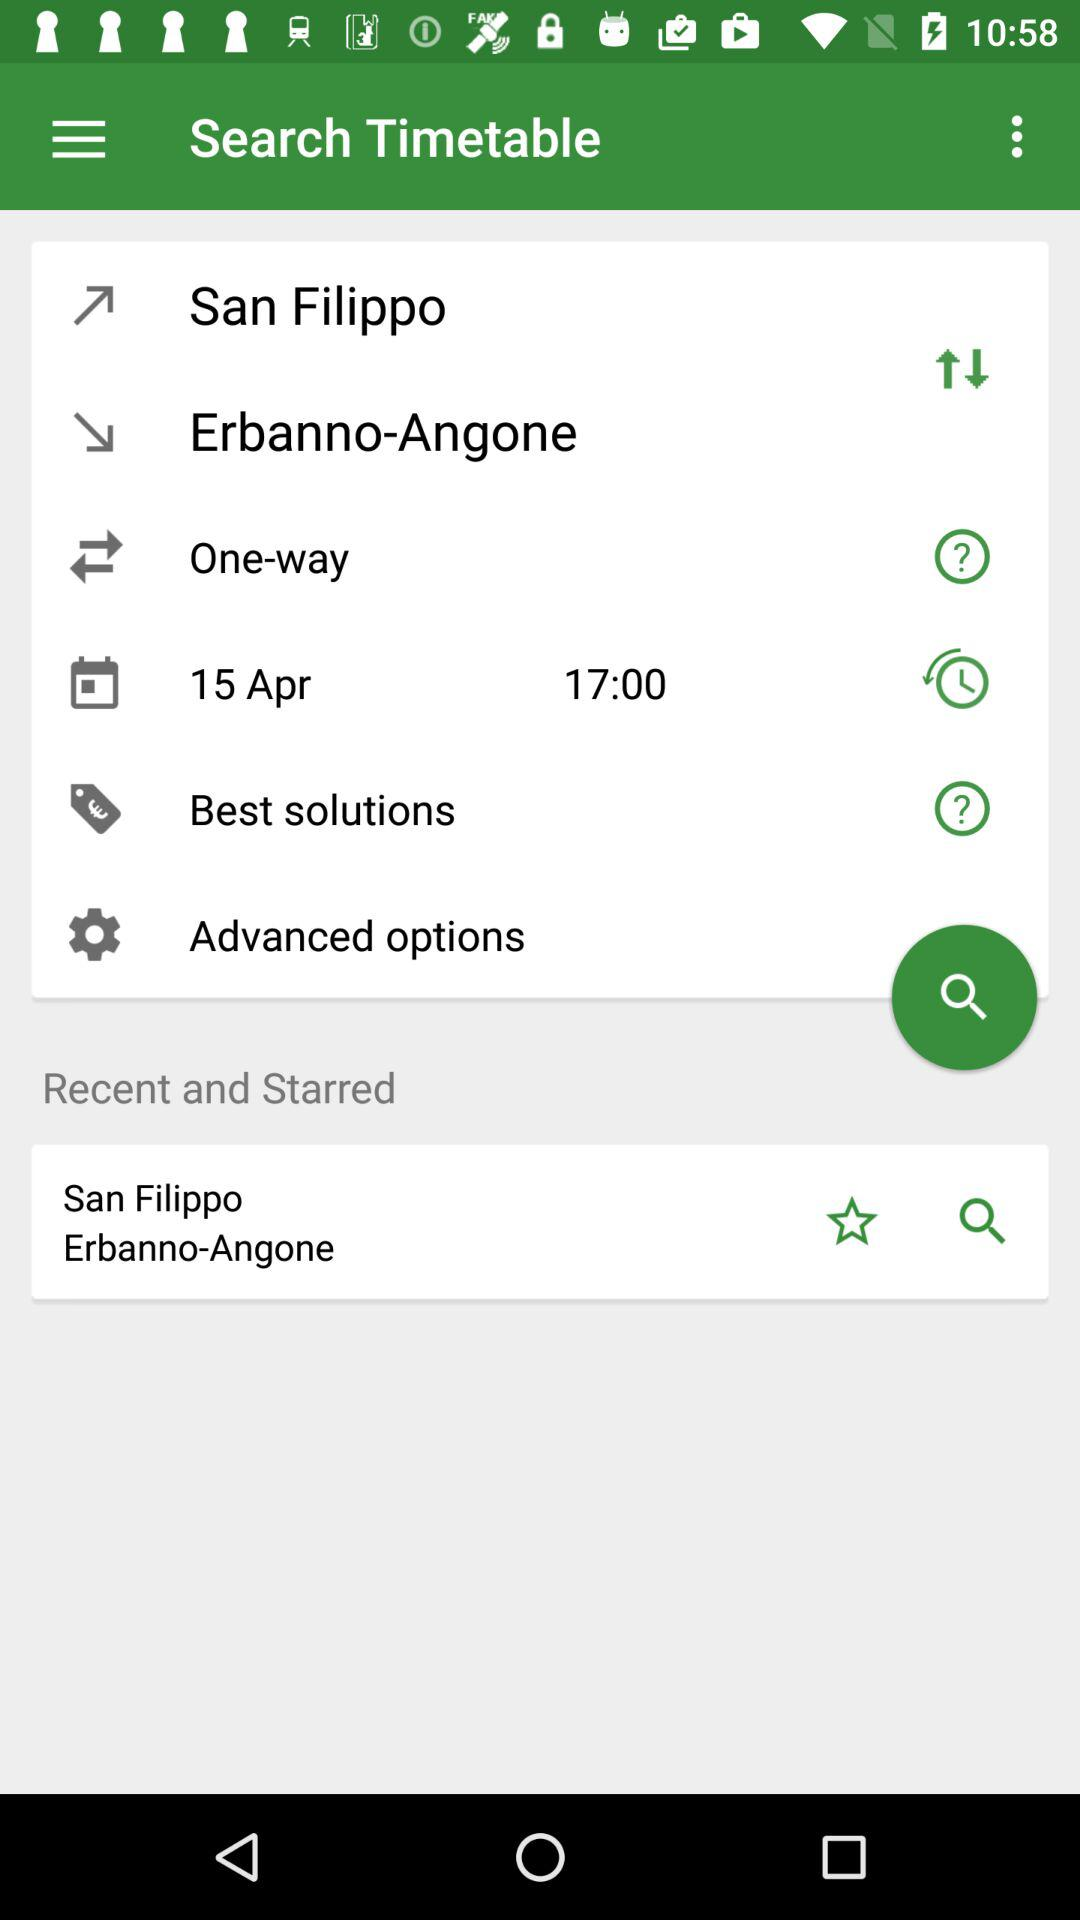What's the shown time? The shown time is 17:00. 